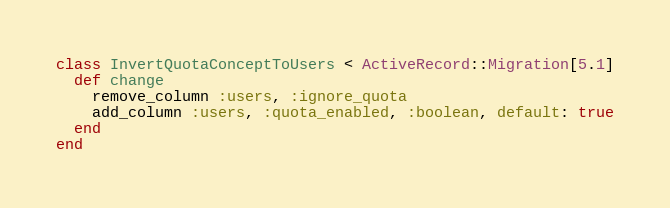Convert code to text. <code><loc_0><loc_0><loc_500><loc_500><_Ruby_>class InvertQuotaConceptToUsers < ActiveRecord::Migration[5.1]
  def change
    remove_column :users, :ignore_quota
    add_column :users, :quota_enabled, :boolean, default: true
  end
end
</code> 